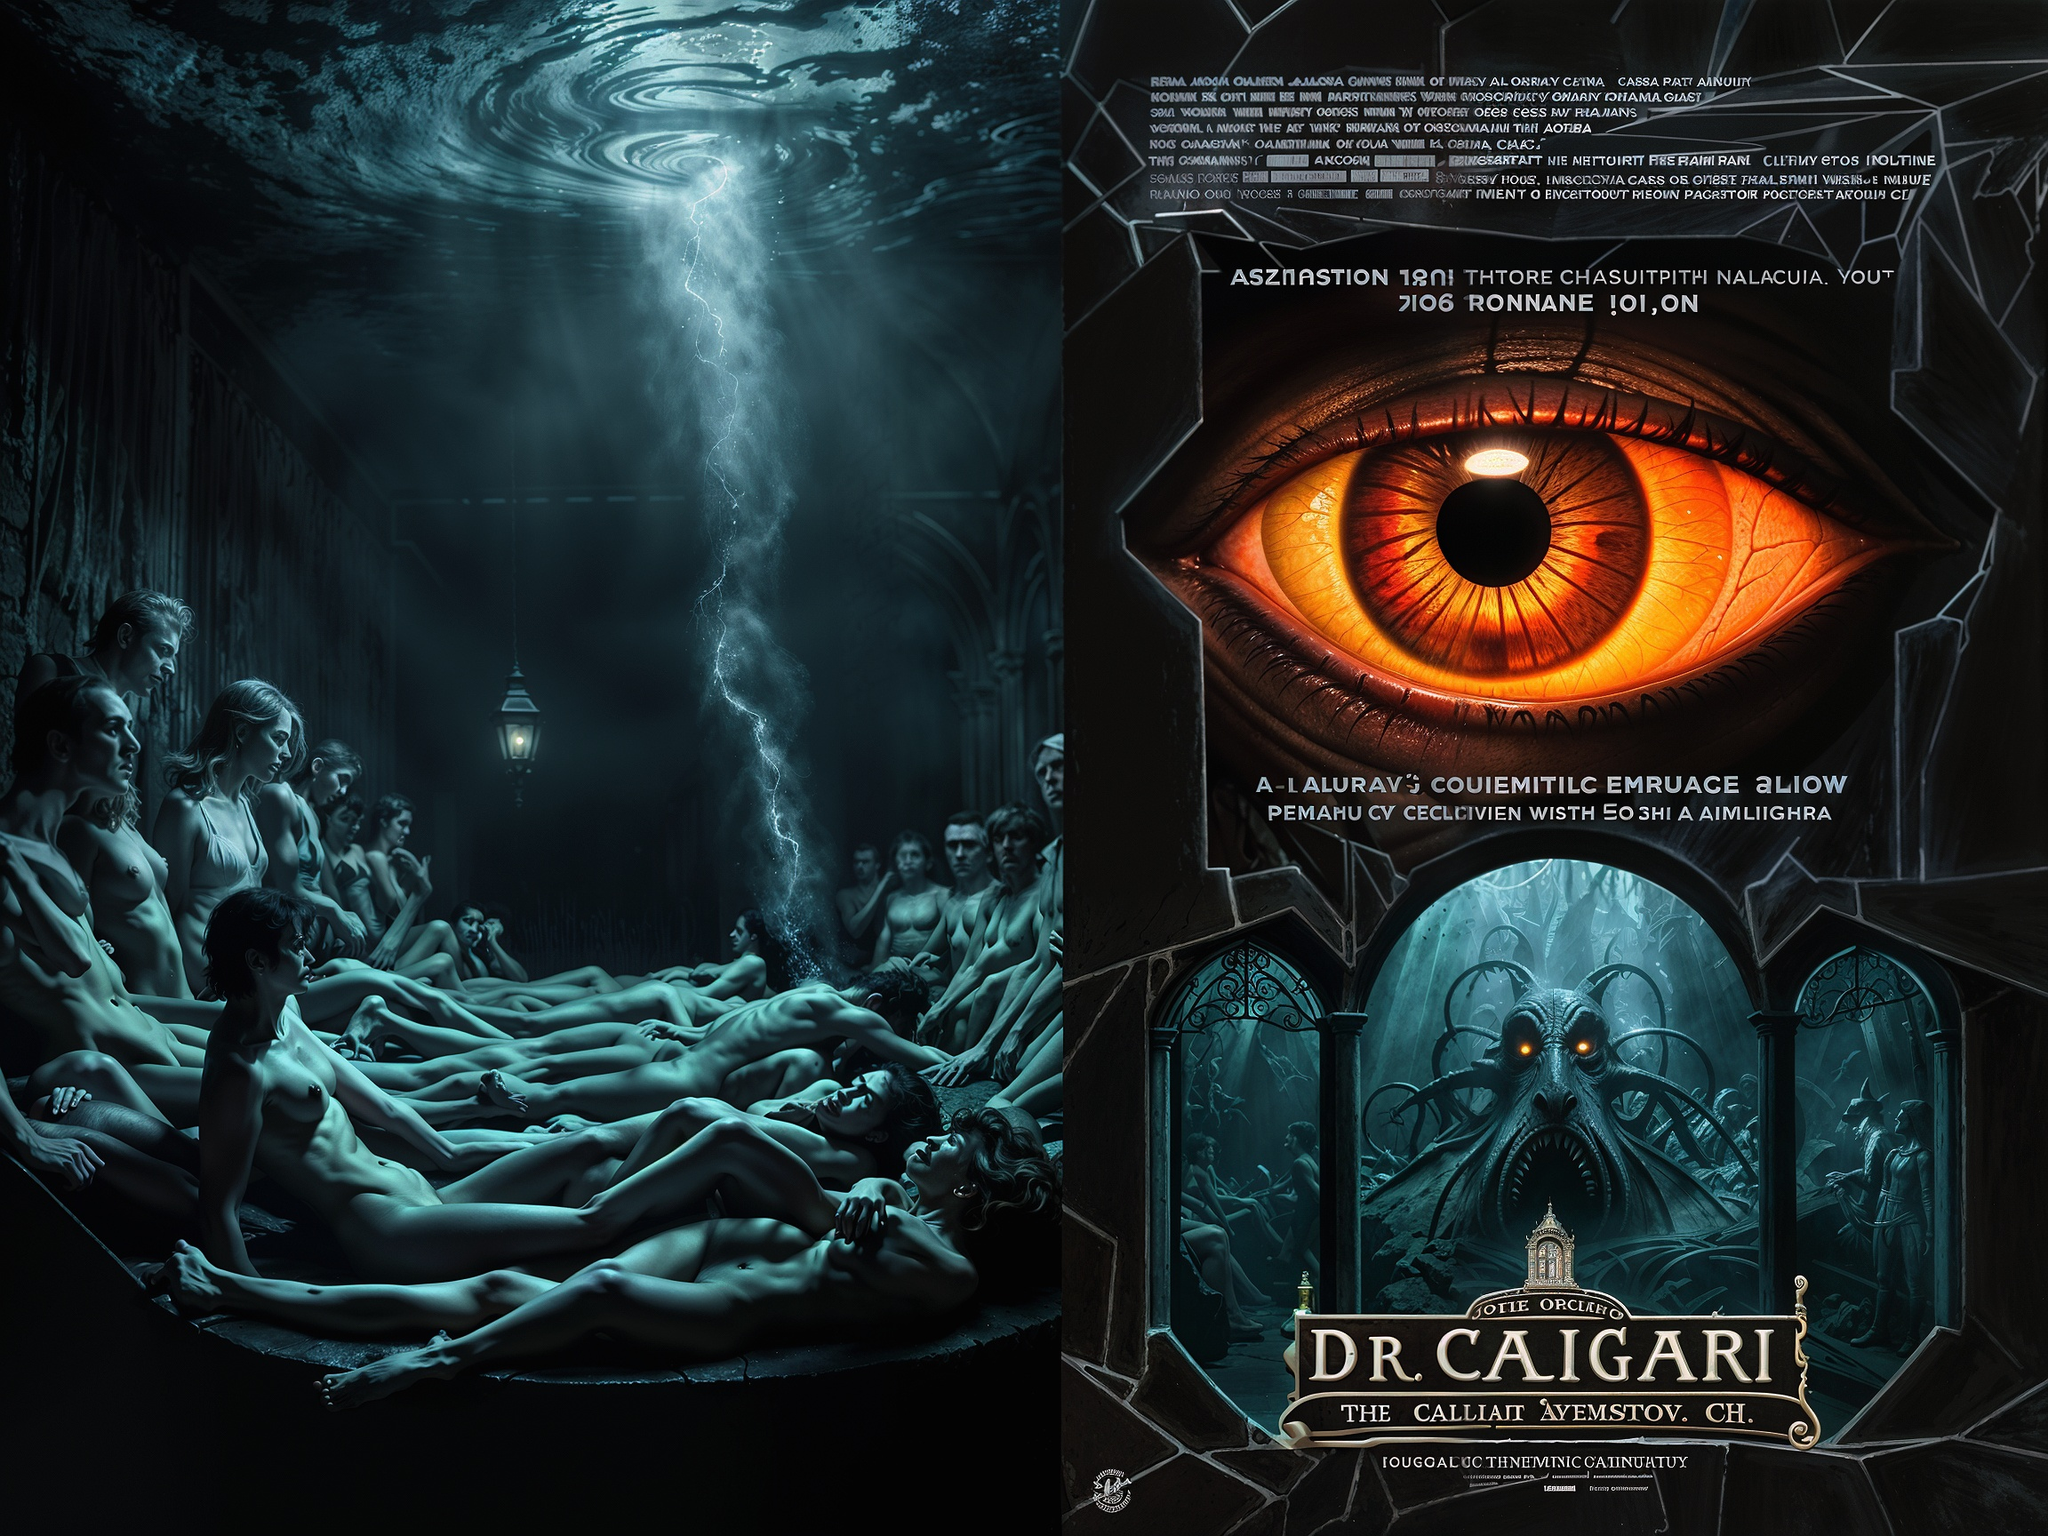escribe una posible historia para esta pelicula The story takes place in a mysterious and secluded spa, known as "The Callian Avens" and owned by a mysterious, albeit somewhat eccentric, doctor named Dr. Caligari. The spa offers a unique and alluring "treatment" that promises to unlock hidden potential and revitalize the body and soul. 

The spa's unique selling point is the "A-Lurav" treatment, a complex and immersive ritual that involves bathing in a dark, murky water surrounded by other naked individuals,  a dimly lit room with a strange atmosphere, and a sense of foreboding.  

As the story unfolds, a group of strangers find themselves drawn to the spa, each with their own hopes and desires. However, as they undergo the "A-Lurav" treatment, they start experiencing unsettling changes. Their memories become hazy, their senses heighten, and their bodies feel different. Soon, they realize that the spa is hiding a sinister secret.

Dr. Caligari is not who he seems. He is a powerful and manipulative individual who has been experimenting on his patients, trying to unlock a hidden part of the human psyche. His ultimate goal is to use the "A-Lurav" treatment to control the minds and bodies of his victims, turning them into loyal followers.

As the story progresses, the group begins to piece together the truth about Dr. Caligari and his evil plan. They must fight for their lives and freedom, but the doctor is powerful and ruthless. With the help of a mysterious stranger, they try to uncover the secrets of the spa and fight back against Dr. Caligari. 

The story ends in a dramatic and unsettling climax, where the true nature of the "A-Lurav" treatment is revealed, and the fate of the group is left hanging in the balance. The film leaves the audience questioning the true meaning of control and the dangers of blind trust. 